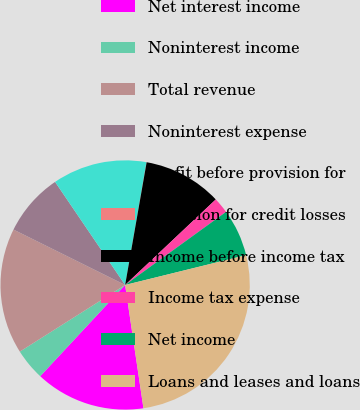<chart> <loc_0><loc_0><loc_500><loc_500><pie_chart><fcel>Net interest income<fcel>Noninterest income<fcel>Total revenue<fcel>Noninterest expense<fcel>Profit before provision for<fcel>Provision for credit losses<fcel>Income before income tax<fcel>Income tax expense<fcel>Net income<fcel>Loans and leases and loans<nl><fcel>14.28%<fcel>4.09%<fcel>16.31%<fcel>8.17%<fcel>12.24%<fcel>0.02%<fcel>10.2%<fcel>2.06%<fcel>6.13%<fcel>26.5%<nl></chart> 